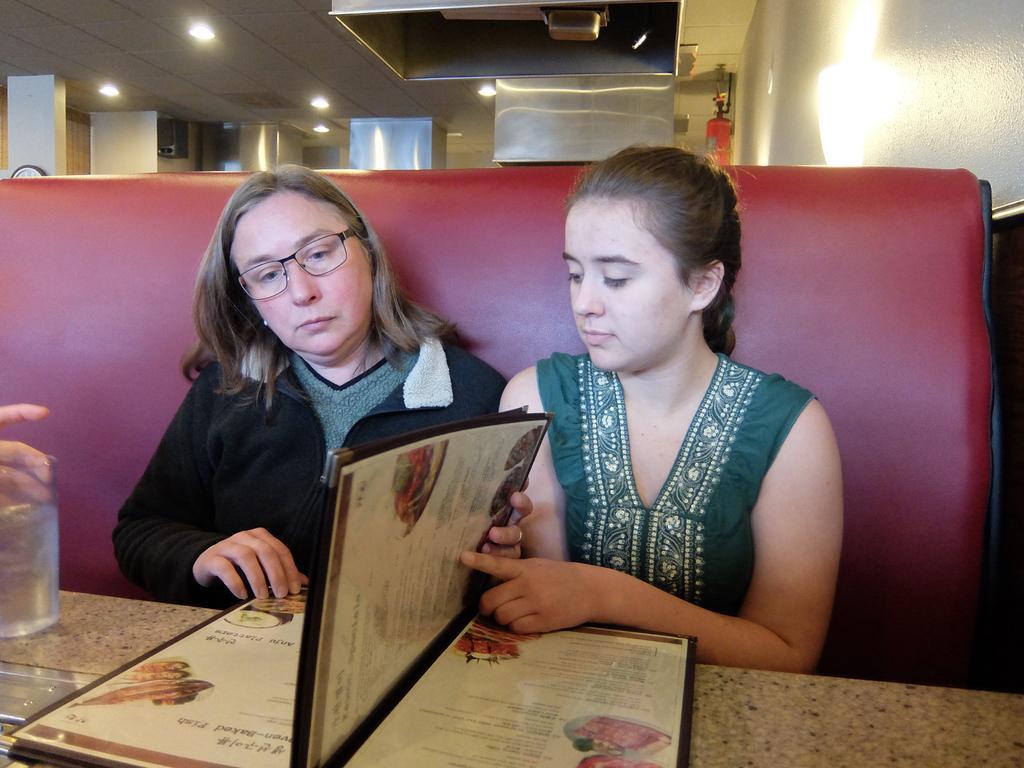Could you give a brief overview of what you see in this image? In this picture we can see two women sitting on a sofa, in front of them we can see a table, menu card, glass and on the left side we can see a person's fingers and in the background we can see a roof, lights, pillars and a fire extinguisher. 